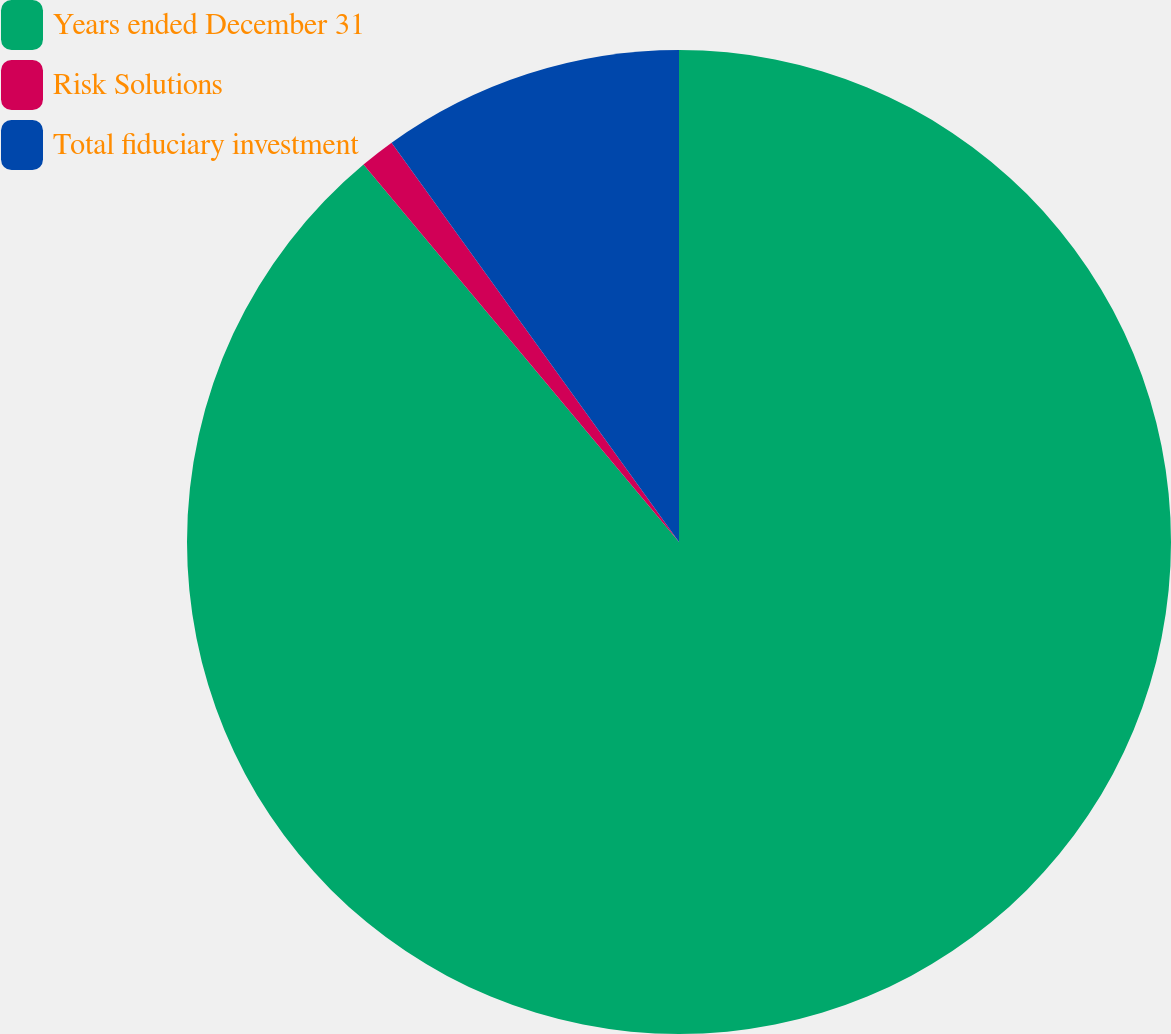<chart> <loc_0><loc_0><loc_500><loc_500><pie_chart><fcel>Years ended December 31<fcel>Risk Solutions<fcel>Total fiduciary investment<nl><fcel>88.93%<fcel>1.15%<fcel>9.93%<nl></chart> 